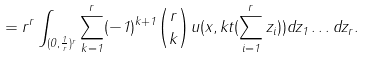<formula> <loc_0><loc_0><loc_500><loc_500>= r ^ { r } \int _ { ( 0 , \frac { 1 } { r } ) ^ { r } } \sum _ { k = 1 } ^ { r } ( - 1 ) ^ { k + 1 } \binom { r } { k } u ( x , k t ( \sum _ { i = 1 } ^ { r } z _ { i } ) ) d z _ { 1 } \dots d z _ { r } .</formula> 